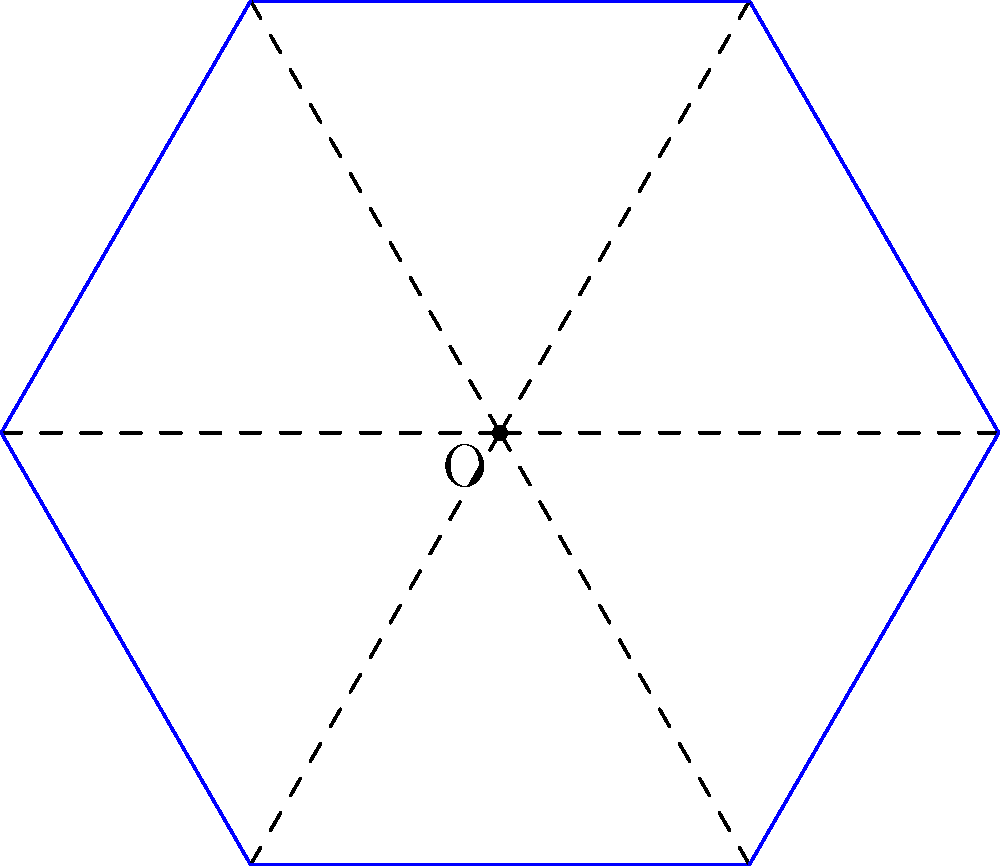You are designing a lighting layout for a hexagonal outdoor seating area with a radius of 6 meters. To ensure even illumination, you decide to place lights along each side of the hexagon. If the total length of lighting strips needed is 36 meters, what is the side length of the hexagon to the nearest tenth of a meter? Let's approach this step-by-step:

1) First, we need to recall the formula for the side length of a regular hexagon given its radius. If $r$ is the radius and $s$ is the side length:

   $s = r \sqrt{3}$

2) We're given that the radius $r = 6$ meters. Let's substitute this into our formula:

   $s = 6 \sqrt{3}$ meters

3) Now, we need to calculate this:

   $s = 6 \sqrt{3} \approx 10.3923$ meters

4) To verify our answer, let's calculate the total perimeter of the hexagon:

   Perimeter $= 6s = 6 \times 10.3923 = 62.3538$ meters

5) The question states that the total length of lighting strips needed is 36 meters. This doesn't match our calculated perimeter, which is correct because the lights are placed along the sides, not around the entire perimeter.

6) Rounding to the nearest tenth of a meter as requested:

   $s \approx 10.4$ meters

Therefore, the side length of the hexagon is approximately 10.4 meters.
Answer: 10.4 meters 